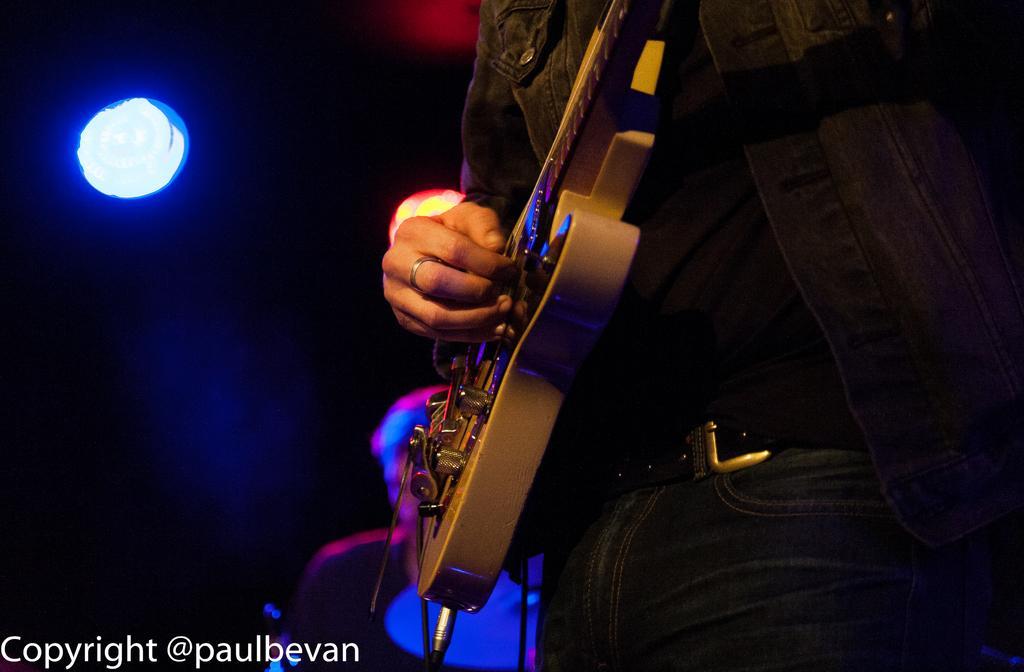Describe this image in one or two sentences. In this picture we can see a person is playing guitar, in the background we can see a light, at the bottom of the image we can find a watermark. 